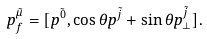Convert formula to latex. <formula><loc_0><loc_0><loc_500><loc_500>p _ { f } ^ { \tilde { \mu } } = [ p ^ { \tilde { 0 } } , \cos \theta p ^ { \tilde { j } } + \sin \theta p _ { \perp } ^ { \tilde { j } } ] .</formula> 